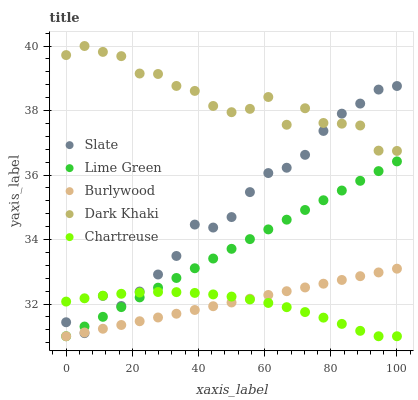Does Chartreuse have the minimum area under the curve?
Answer yes or no. Yes. Does Dark Khaki have the maximum area under the curve?
Answer yes or no. Yes. Does Slate have the minimum area under the curve?
Answer yes or no. No. Does Slate have the maximum area under the curve?
Answer yes or no. No. Is Lime Green the smoothest?
Answer yes or no. Yes. Is Dark Khaki the roughest?
Answer yes or no. Yes. Is Slate the smoothest?
Answer yes or no. No. Is Slate the roughest?
Answer yes or no. No. Does Burlywood have the lowest value?
Answer yes or no. Yes. Does Slate have the lowest value?
Answer yes or no. No. Does Dark Khaki have the highest value?
Answer yes or no. Yes. Does Slate have the highest value?
Answer yes or no. No. Is Burlywood less than Dark Khaki?
Answer yes or no. Yes. Is Dark Khaki greater than Lime Green?
Answer yes or no. Yes. Does Slate intersect Dark Khaki?
Answer yes or no. Yes. Is Slate less than Dark Khaki?
Answer yes or no. No. Is Slate greater than Dark Khaki?
Answer yes or no. No. Does Burlywood intersect Dark Khaki?
Answer yes or no. No. 